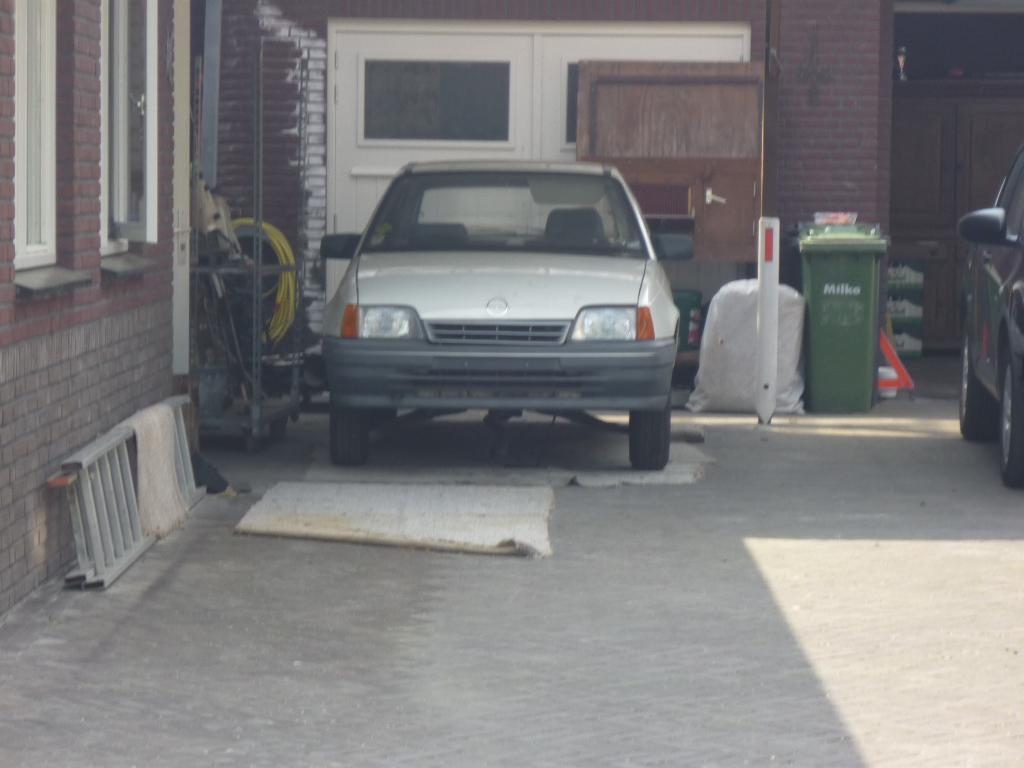What types of vehicles can be seen in the image? There are vehicles in the image, but the specific types are not mentioned. What is the purpose of the dustbin in the image? The dustbin is likely used for waste disposal. What is the bag used for in the image? The purpose of the bag is not specified in the image. What is the ladder used for in the image? The ladder is likely used for reaching higher areas. What are the pipes used for in the image? The pipes are likely used for transporting water or other fluids. Can you describe any other objects in the image? There are other objects in the image, but their specific details are not mentioned. What can be seen in the background of the image? There is a house in the background of the image. Where is the letter addressed to in the image? There is no letter present in the image. What type of faucet is visible in the image? There is no faucet present in the image. 